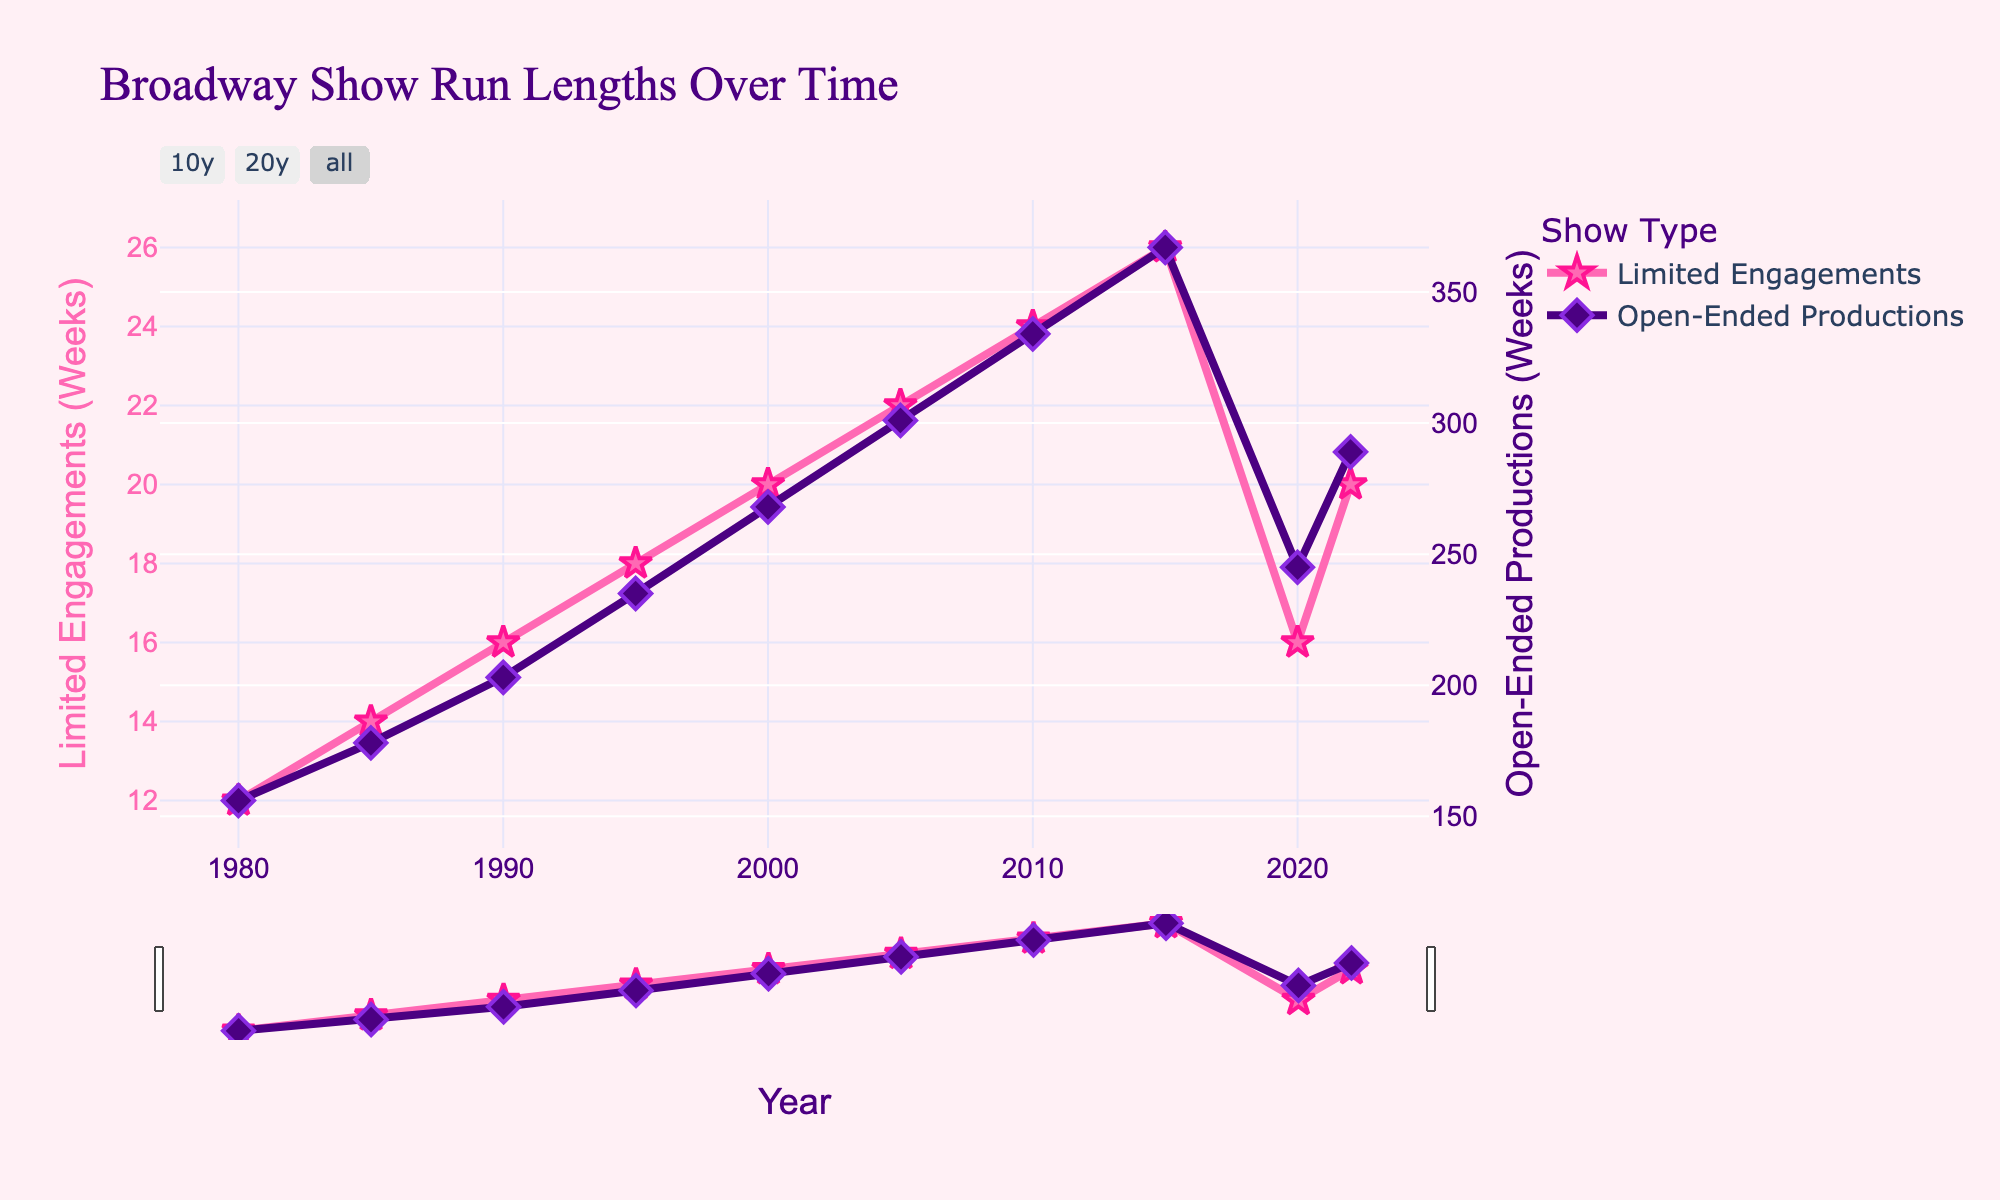What years saw the highest average run lengths for limited engagements and open-ended productions? The highest average run length for limited engagements occurred in 2015 (26 weeks) and for open-ended productions, it was also in 2015 with 367 weeks. This can be observed by looking at the peaks in the respective lines on the graph.
Answer: 2015 for both How did the average run length for open-ended productions in 2010 compare to that in 2020? The average run length for open-ended productions in 2010 was 334 weeks, while in 2020 it decreased to 245 weeks. This shows a decrease of 89 weeks.
Answer: Decreased by 89 weeks Which type of production showed a decrease in average run length between 2015 and 2020? By comparing the values from the chart, limited engagements decreased from 26 weeks in 2015 to 16 weeks in 2020. This type shows a clear decrease.
Answer: Limited engagements What is the average increase in run length per 5 years for limited engagements from 1980 to 2015? First, find the total increase from 1980 (12 weeks) to 2015 (26 weeks), which is 14 weeks. There are 7 intervals of 5 years between these years, so the average increase per 5 years is 14/7 = 2 weeks.
Answer: 2 weeks Between which consecutive 5-year intervals did limited engagements see the greatest increase? The greatest increase occurred between 2015 and 2020, where the increase was from 26 weeks to 16 weeks, which is a decrease of 10 weeks. This means it had the largest negative change.
Answer: 2015 to 2020 Which type of production had more stable average run lengths, limited engagements or open-ended productions? Open-ended productions had a more steady increase over time compared to limited engagements, which showed varied changes and even a decrease in 2020.
Answer: Open-ended productions What is the difference in the average run length between the two production types in the year 2000? The average run length for limited engagements was 20 weeks, and for open-ended productions, it was 268 weeks. The difference is 268 - 20 = 248 weeks.
Answer: 248 weeks How did the average run length of limited engagements change between 2000 and 2005? The length increased from 20 weeks in 2000 to 22 weeks in 2005. Therefore, the change is 22 - 20 = 2 weeks.
Answer: Increased by 2 weeks Looking at the visual cues, which type of production has a diamond-shaped marker indicating average run lengths? The diamond-shaped markers indicate the average run lengths for open-ended productions.
Answer: Open-ended productions In what year did the limited engagements' average run length reach 24 weeks? Observing the plot, the limited engagements' average run length reached 24 weeks in the year 2010.
Answer: 2010 